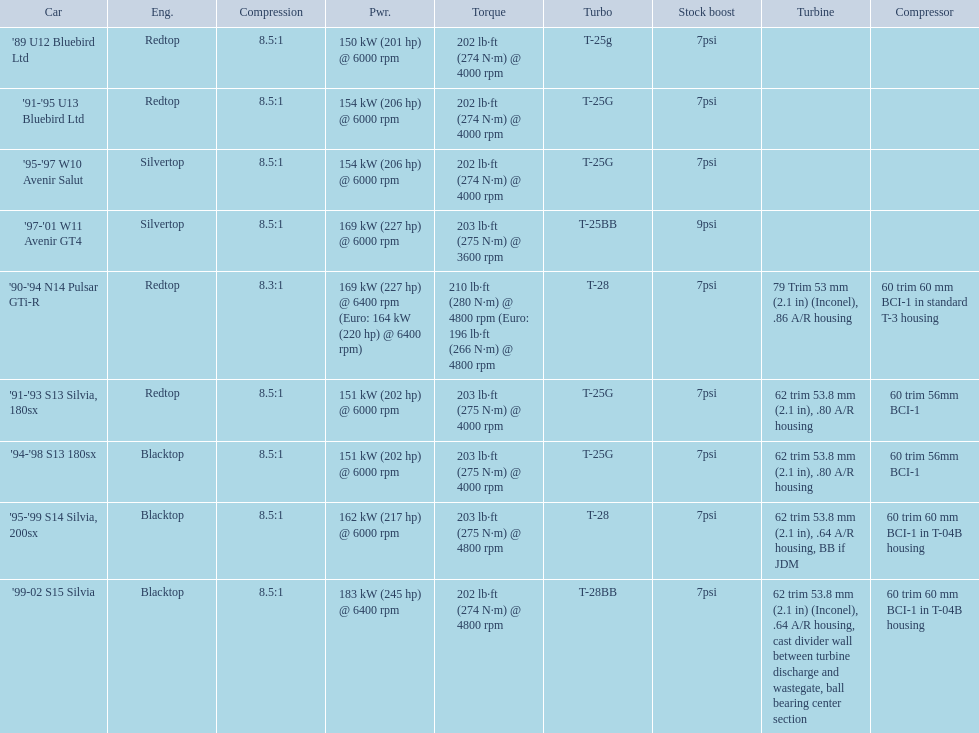Which cars featured blacktop engines? '94-'98 S13 180sx, '95-'99 S14 Silvia, 200sx, '99-02 S15 Silvia. Which of these had t-04b compressor housings? '95-'99 S14 Silvia, 200sx, '99-02 S15 Silvia. Which one of these has the highest horsepower? '99-02 S15 Silvia. 